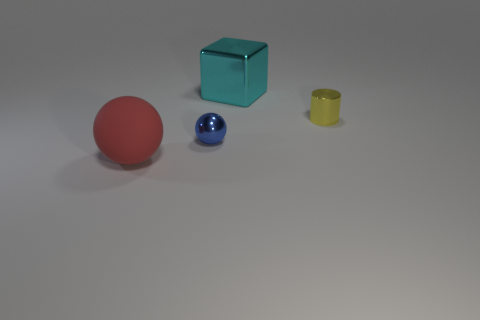Can you tell me what colors are the objects in the image? Certainly! The objects present in the image are of the following colors: one is red, another is blue, there's also an object appearing to be teal or turquoise, and a final one that looks yellow. 